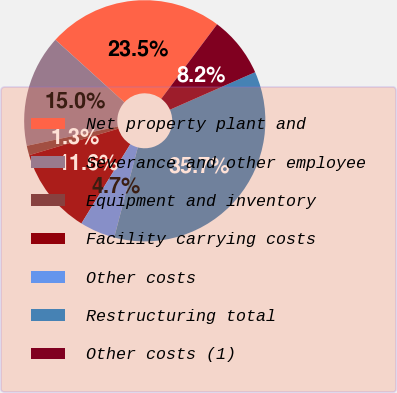Convert chart. <chart><loc_0><loc_0><loc_500><loc_500><pie_chart><fcel>Net property plant and<fcel>Severance and other employee<fcel>Equipment and inventory<fcel>Facility carrying costs<fcel>Other costs<fcel>Restructuring total<fcel>Other costs (1)<nl><fcel>23.52%<fcel>15.04%<fcel>1.28%<fcel>11.6%<fcel>4.72%<fcel>35.68%<fcel>8.16%<nl></chart> 